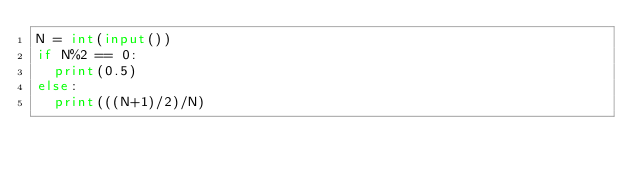Convert code to text. <code><loc_0><loc_0><loc_500><loc_500><_Python_>N = int(input())
if N%2 == 0:
  print(0.5)
else:
  print(((N+1)/2)/N)</code> 